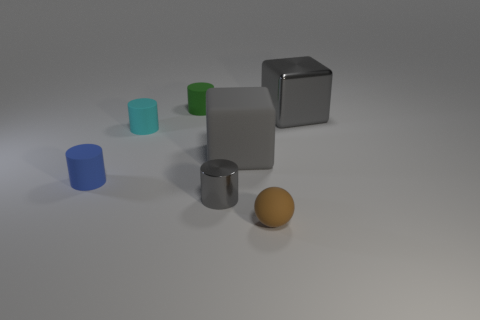What color is the small object that is on the right side of the gray block that is to the left of the matte ball?
Ensure brevity in your answer.  Brown. What number of other objects are the same material as the tiny gray cylinder?
Your response must be concise. 1. There is a gray object on the left side of the matte block; how many cubes are in front of it?
Offer a terse response. 0. Are there any other things that have the same shape as the tiny blue matte object?
Your response must be concise. Yes. Does the matte thing in front of the tiny blue rubber thing have the same color as the cylinder to the right of the green thing?
Ensure brevity in your answer.  No. Is the number of tiny gray metal cylinders less than the number of tiny cyan metal balls?
Offer a terse response. No. There is a large gray thing that is on the left side of the gray metallic object that is behind the small metal cylinder; what shape is it?
Provide a short and direct response. Cube. Is there anything else that has the same size as the metal cylinder?
Keep it short and to the point. Yes. There is a shiny object in front of the large gray thing left of the brown matte thing that is in front of the small blue cylinder; what is its shape?
Provide a succinct answer. Cylinder. What number of things are either big gray things to the left of the gray metallic cube or small things that are to the left of the small green cylinder?
Your response must be concise. 3. 